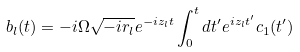<formula> <loc_0><loc_0><loc_500><loc_500>b _ { l } ( t ) = - i \Omega \sqrt { - i r _ { l } } e ^ { - i z _ { l } t } \int _ { 0 } ^ { t } d t ^ { \prime } e ^ { i z _ { l } t ^ { \prime } } c _ { 1 } ( t ^ { \prime } )</formula> 